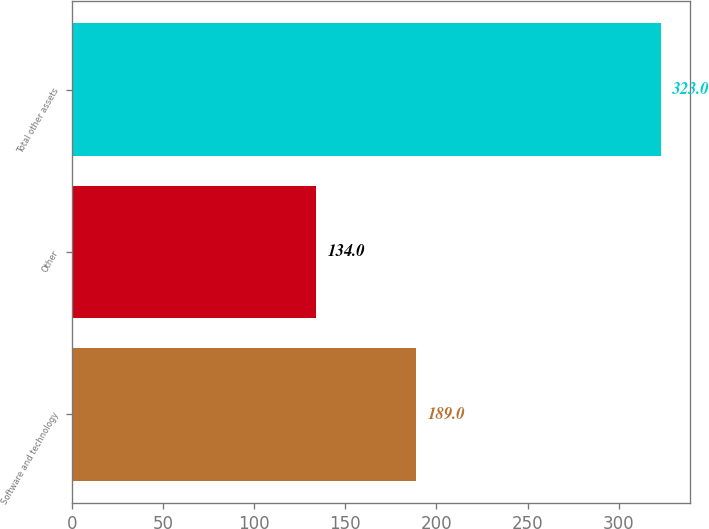Convert chart to OTSL. <chart><loc_0><loc_0><loc_500><loc_500><bar_chart><fcel>Software and technology<fcel>Other<fcel>Total other assets<nl><fcel>189<fcel>134<fcel>323<nl></chart> 